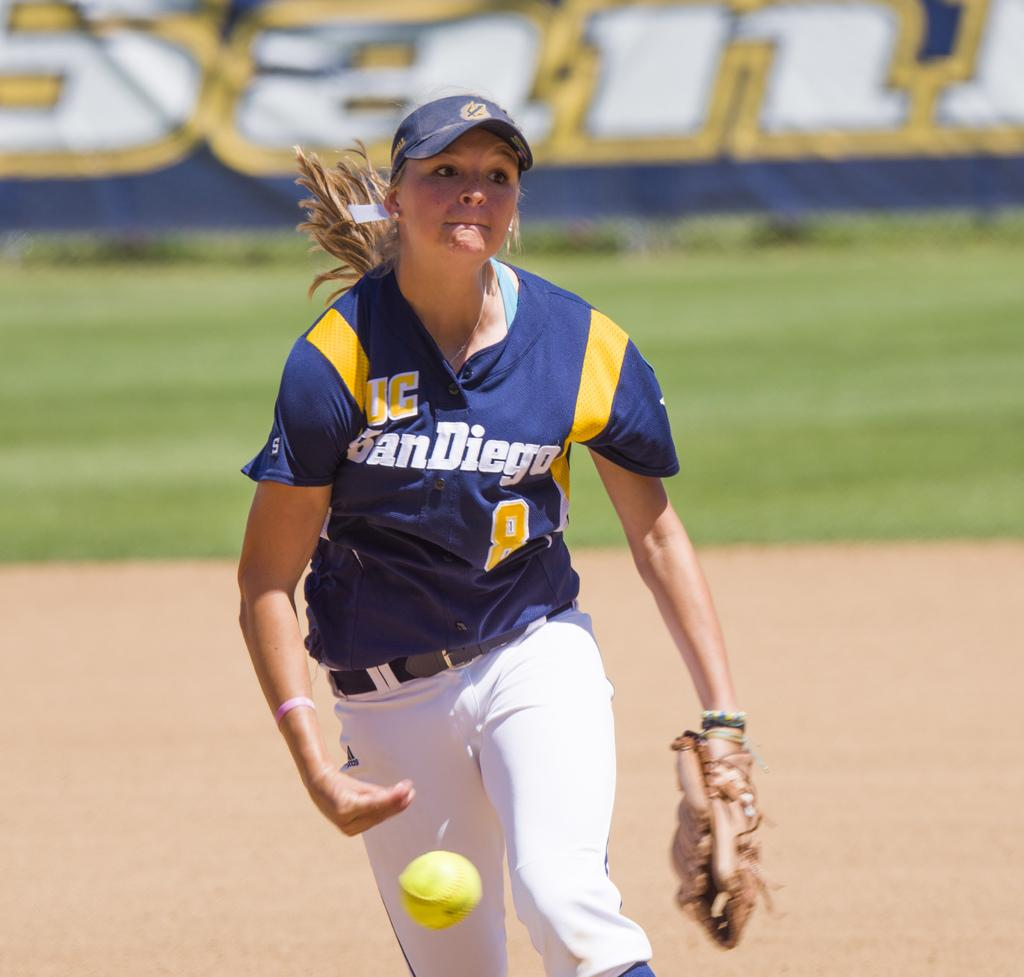<image>
Create a compact narrative representing the image presented. a girl with a san diego jersey on playing baseball 